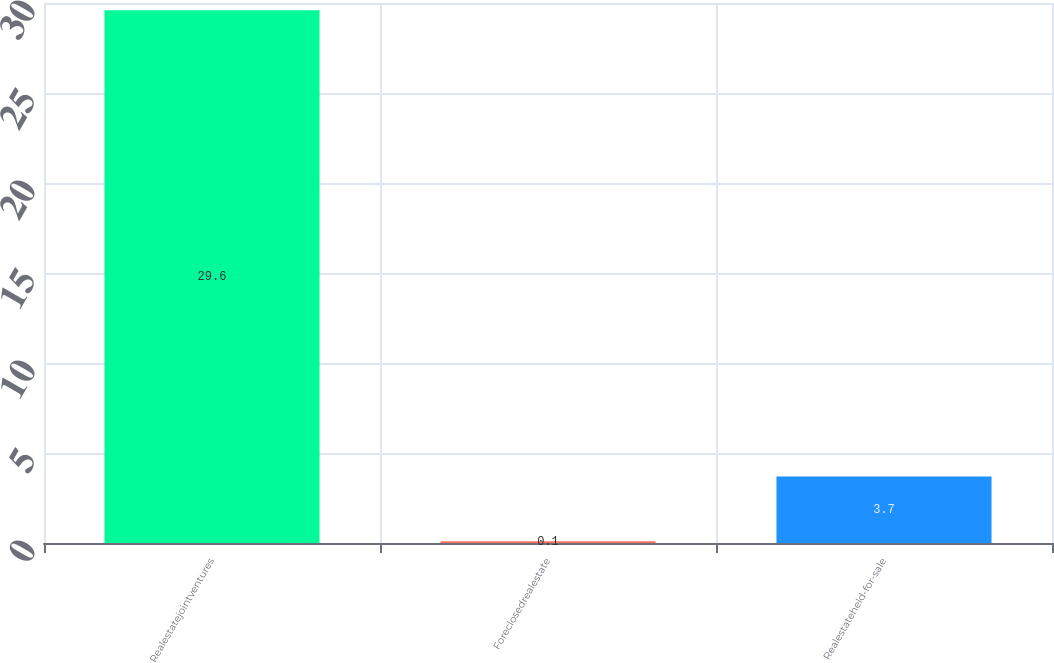Convert chart. <chart><loc_0><loc_0><loc_500><loc_500><bar_chart><fcel>Realestatejointventures<fcel>Foreclosedrealestate<fcel>Realestateheld-for-sale<nl><fcel>29.6<fcel>0.1<fcel>3.7<nl></chart> 